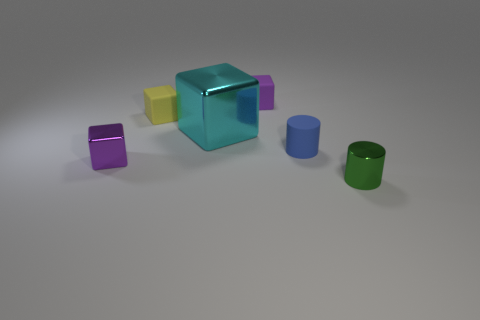Add 1 yellow objects. How many objects exist? 7 Subtract all cylinders. How many objects are left? 4 Subtract all tiny blue matte cylinders. Subtract all small green metallic objects. How many objects are left? 4 Add 4 large things. How many large things are left? 5 Add 3 tiny yellow rubber cylinders. How many tiny yellow rubber cylinders exist? 3 Subtract 0 purple spheres. How many objects are left? 6 